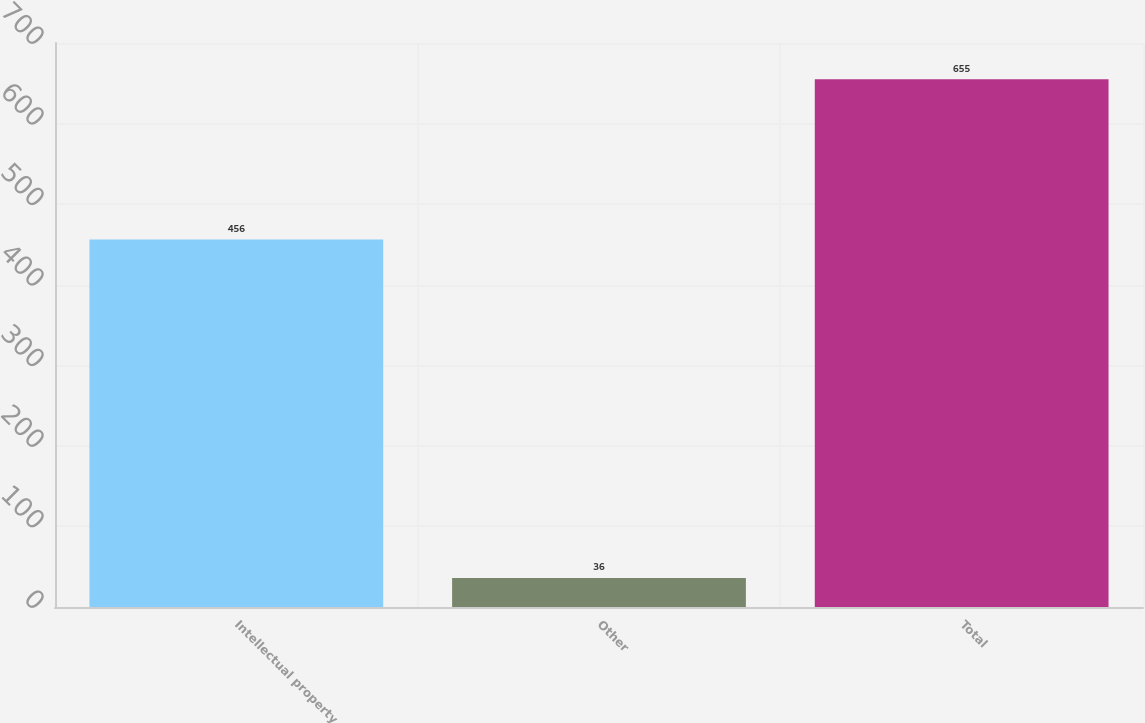Convert chart. <chart><loc_0><loc_0><loc_500><loc_500><bar_chart><fcel>Intellectual property<fcel>Other<fcel>Total<nl><fcel>456<fcel>36<fcel>655<nl></chart> 